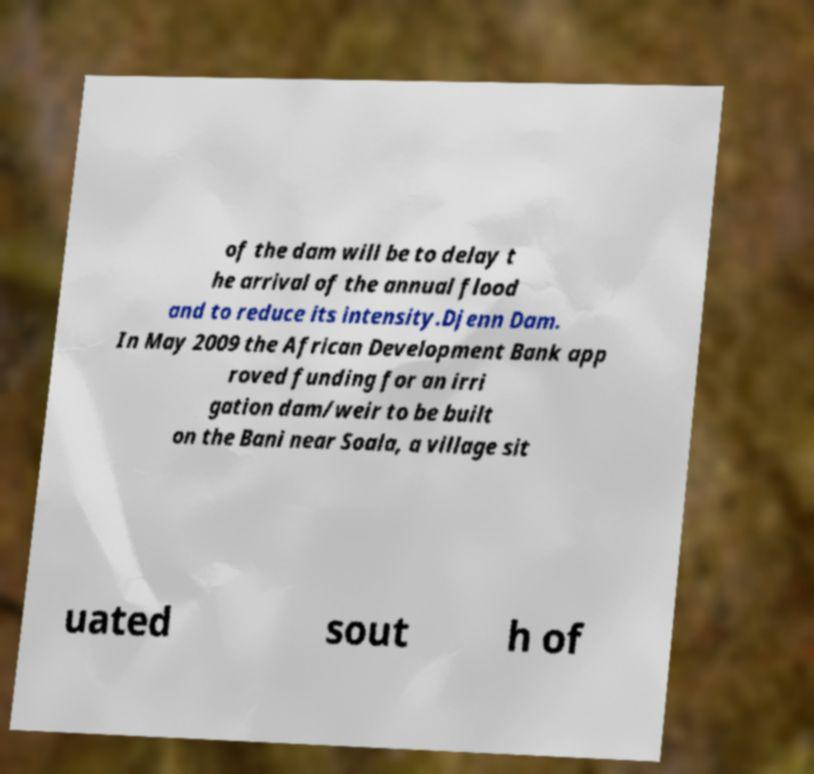What messages or text are displayed in this image? I need them in a readable, typed format. of the dam will be to delay t he arrival of the annual flood and to reduce its intensity.Djenn Dam. In May 2009 the African Development Bank app roved funding for an irri gation dam/weir to be built on the Bani near Soala, a village sit uated sout h of 